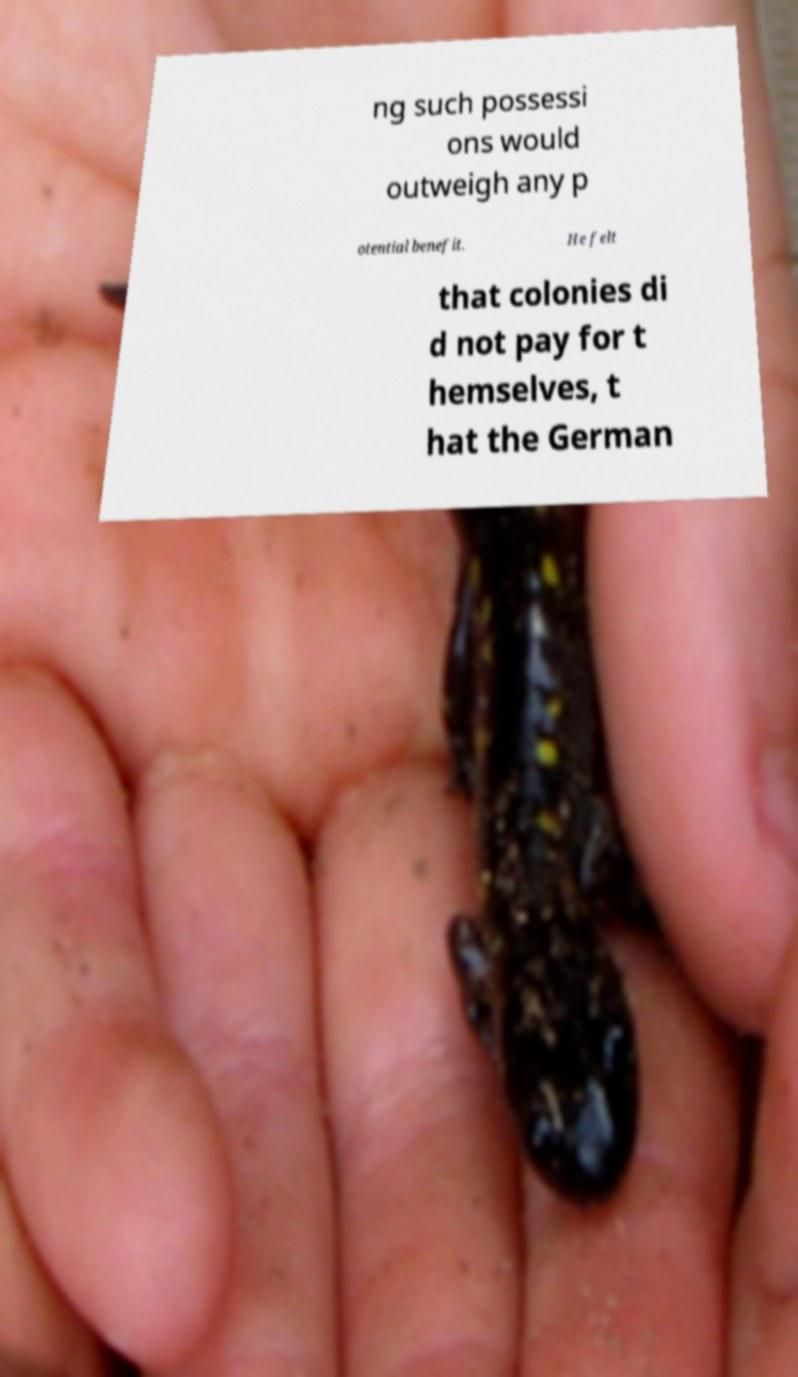Could you assist in decoding the text presented in this image and type it out clearly? ng such possessi ons would outweigh any p otential benefit. He felt that colonies di d not pay for t hemselves, t hat the German 